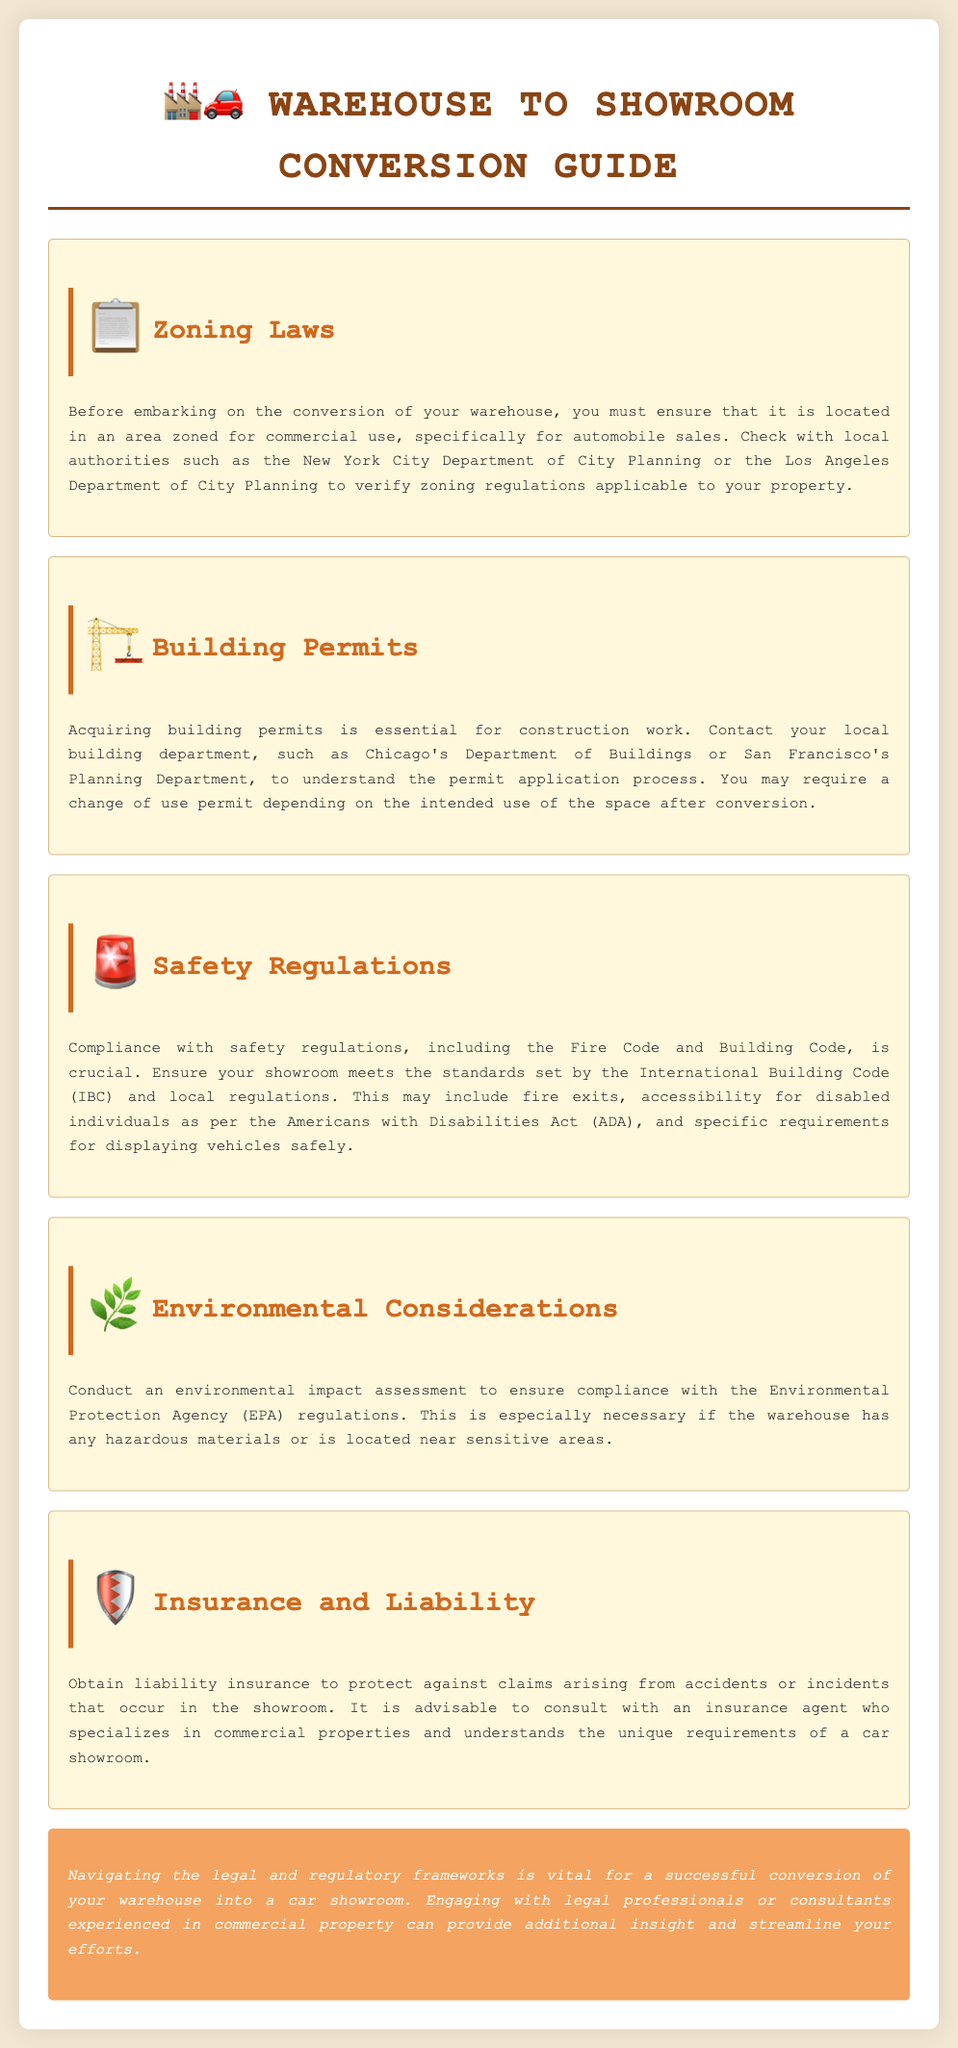What must be checked before converting a warehouse? It is important to check that the warehouse is located in an area zoned for commercial use for automobile sales before conversion.
Answer: Zoning laws Which departments should be contacted for building permits? Specific local building departments like Chicago's Department of Buildings or San Francisco's Planning Department should be contacted for building permits.
Answer: Local building department What code must the showroom comply with for safety regulations? The showroom must meet standards set by the International Building Code (IBC) for safety regulations.
Answer: International Building Code What is necessary to protect against claims in the showroom? Liability insurance is necessary to protect against claims arising from accidents or incidents in the showroom.
Answer: Liability insurance What is a crucial step regarding environmental considerations? Conducting an environmental impact assessment is a crucial step concerning environmental considerations for the conversion.
Answer: Environmental impact assessment What specific requirement must be met for accessibility in the showroom? The showroom must meet specific requirements for accessibility as per the Americans with Disabilities Act (ADA).
Answer: Americans with Disabilities Act Which agency's regulations should be complied with for environmental considerations? Compliance with the Environmental Protection Agency (EPA) regulations is necessary for environmental considerations.
Answer: Environmental Protection Agency Why is it advisable to consult with legal professionals? Consulting legal professionals is advisable due to their expertise in navigating the legal and regulatory frameworks for commercial property conversion.
Answer: Legal professionals 